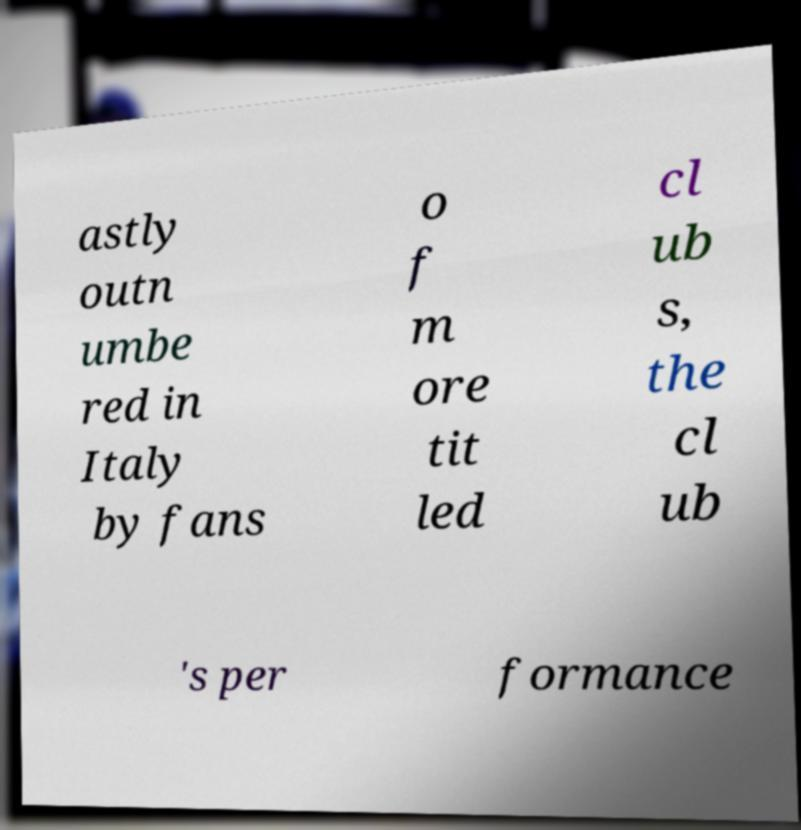Can you accurately transcribe the text from the provided image for me? astly outn umbe red in Italy by fans o f m ore tit led cl ub s, the cl ub 's per formance 